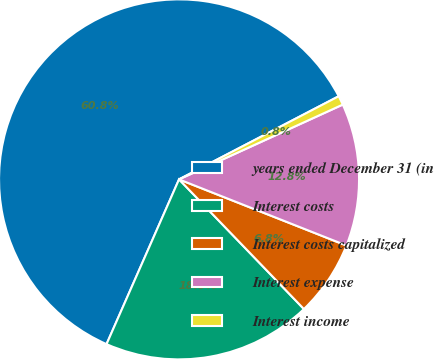Convert chart. <chart><loc_0><loc_0><loc_500><loc_500><pie_chart><fcel>years ended December 31 (in<fcel>Interest costs<fcel>Interest costs capitalized<fcel>Interest expense<fcel>Interest income<nl><fcel>60.77%<fcel>18.8%<fcel>6.81%<fcel>12.81%<fcel>0.82%<nl></chart> 